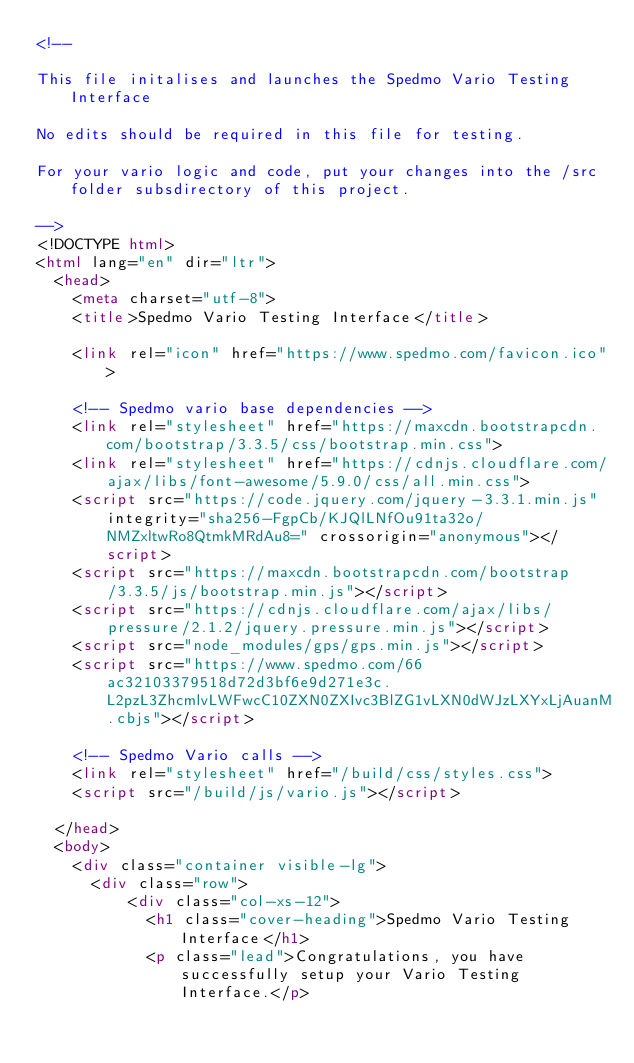<code> <loc_0><loc_0><loc_500><loc_500><_HTML_><!--

This file initalises and launches the Spedmo Vario Testing Interface

No edits should be required in this file for testing.

For your vario logic and code, put your changes into the /src folder subsdirectory of this project.

-->
<!DOCTYPE html>
<html lang="en" dir="ltr">
  <head>
    <meta charset="utf-8">
    <title>Spedmo Vario Testing Interface</title>

    <link rel="icon" href="https://www.spedmo.com/favicon.ico">

    <!-- Spedmo vario base dependencies -->
    <link rel="stylesheet" href="https://maxcdn.bootstrapcdn.com/bootstrap/3.3.5/css/bootstrap.min.css">
    <link rel="stylesheet" href="https://cdnjs.cloudflare.com/ajax/libs/font-awesome/5.9.0/css/all.min.css">
    <script src="https://code.jquery.com/jquery-3.3.1.min.js" integrity="sha256-FgpCb/KJQlLNfOu91ta32o/NMZxltwRo8QtmkMRdAu8=" crossorigin="anonymous"></script>
    <script src="https://maxcdn.bootstrapcdn.com/bootstrap/3.3.5/js/bootstrap.min.js"></script>
    <script src="https://cdnjs.cloudflare.com/ajax/libs/pressure/2.1.2/jquery.pressure.min.js"></script>
    <script src="node_modules/gps/gps.min.js"></script>
    <script src="https://www.spedmo.com/66ac32103379518d72d3bf6e9d271e3c.L2pzL3ZhcmlvLWFwcC10ZXN0ZXIvc3BlZG1vLXN0dWJzLXYxLjAuanM.cbjs"></script>

    <!-- Spedmo Vario calls -->
    <link rel="stylesheet" href="/build/css/styles.css">
    <script src="/build/js/vario.js"></script>

  </head>
  <body>
    <div class="container visible-lg">
      <div class="row">
          <div class="col-xs-12">
            <h1 class="cover-heading">Spedmo Vario Testing Interface</h1>
            <p class="lead">Congratulations, you have successfully setup your Vario Testing Interface.</p></code> 